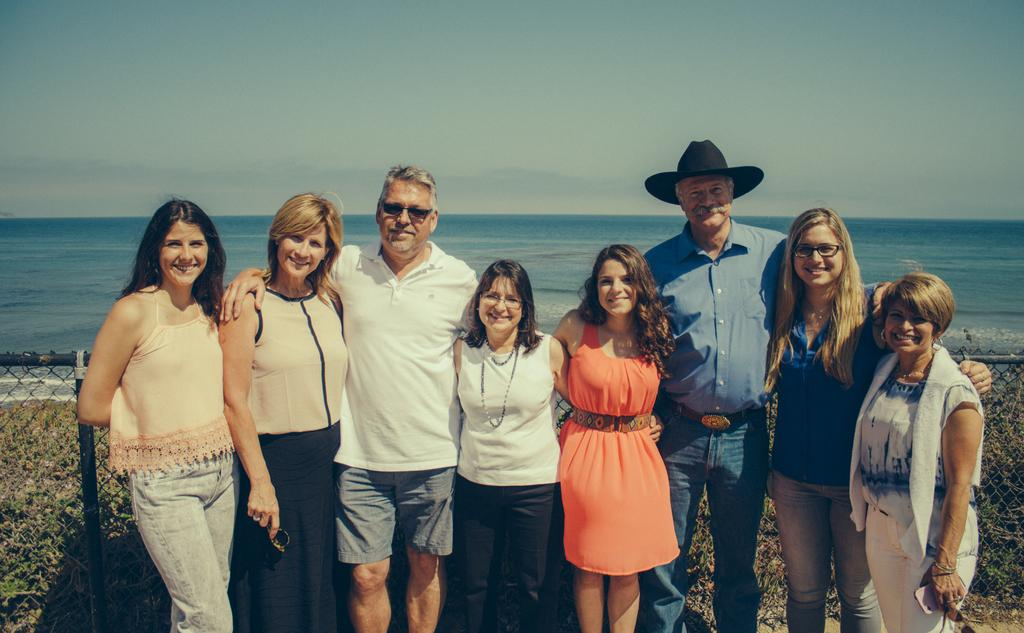How many people are in the image? There are people in the image, but the exact number is not specified. What are the people doing in the image? The people are standing and smiling in the image. What can be seen in the background of the image? There is a sea and sky visible in the background of the image. What is located in the center of the image? There is a fence in the center of the image. What type of cable can be seen connecting the scarecrow to the clouds in the image? There is no cable, scarecrow, or clouds present in the image. 